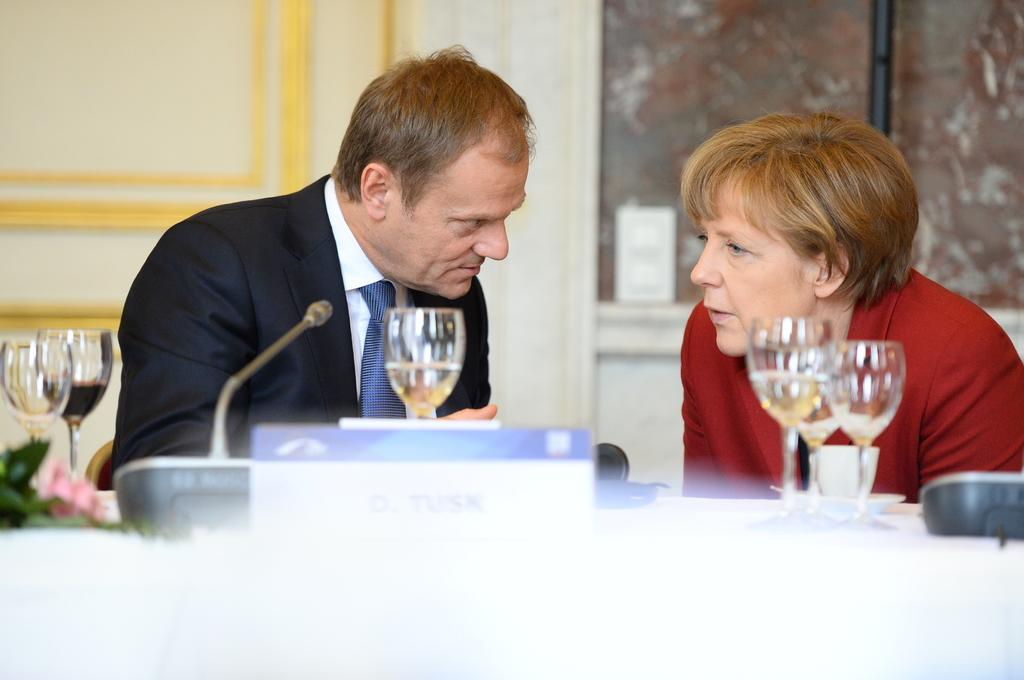What is the man in the image wearing? The man in the image is wearing a black suit. What is the woman in the image wearing? The woman in the image is wearing a red jacket. Where are the man and woman sitting in the image? The man and woman are sitting in front of a table. What objects can be seen on the table? There are wine glasses and a microphone on the table. What is visible in the background of the image? There is a wall visible in the background. How many sticks are being used by the man and woman in the image? There are no sticks present in the image. What type of wish does the microphone grant in the image? The microphone does not grant wishes in the image; it is an object used for amplifying sound. 